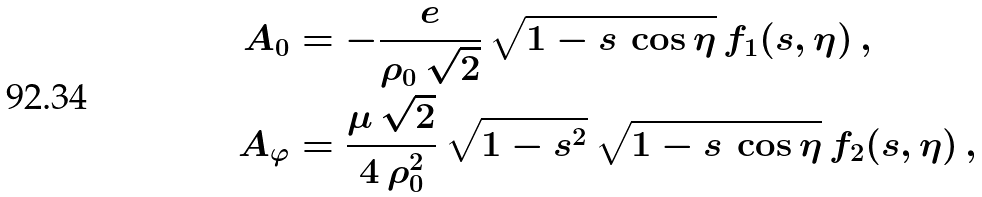<formula> <loc_0><loc_0><loc_500><loc_500>A _ { 0 } & = - \frac { e } { \rho _ { 0 } \, \sqrt { 2 } } \, \sqrt { 1 - s \, \cos \eta } \, f _ { 1 } ( s , \eta ) \, , \\ A _ { \varphi } & = \frac { \mu \, \sqrt { 2 } } { 4 \, \rho _ { 0 } ^ { 2 } } \, \sqrt { 1 - s ^ { 2 } } \, \sqrt { 1 - s \, \cos \eta } \, f _ { 2 } ( s , \eta ) \, ,</formula> 